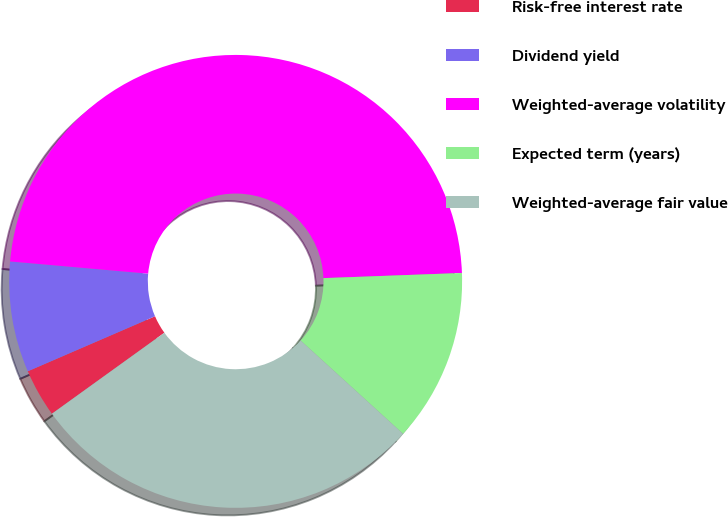Convert chart. <chart><loc_0><loc_0><loc_500><loc_500><pie_chart><fcel>Risk-free interest rate<fcel>Dividend yield<fcel>Weighted-average volatility<fcel>Expected term (years)<fcel>Weighted-average fair value<nl><fcel>3.44%<fcel>7.9%<fcel>48.01%<fcel>12.35%<fcel>28.31%<nl></chart> 